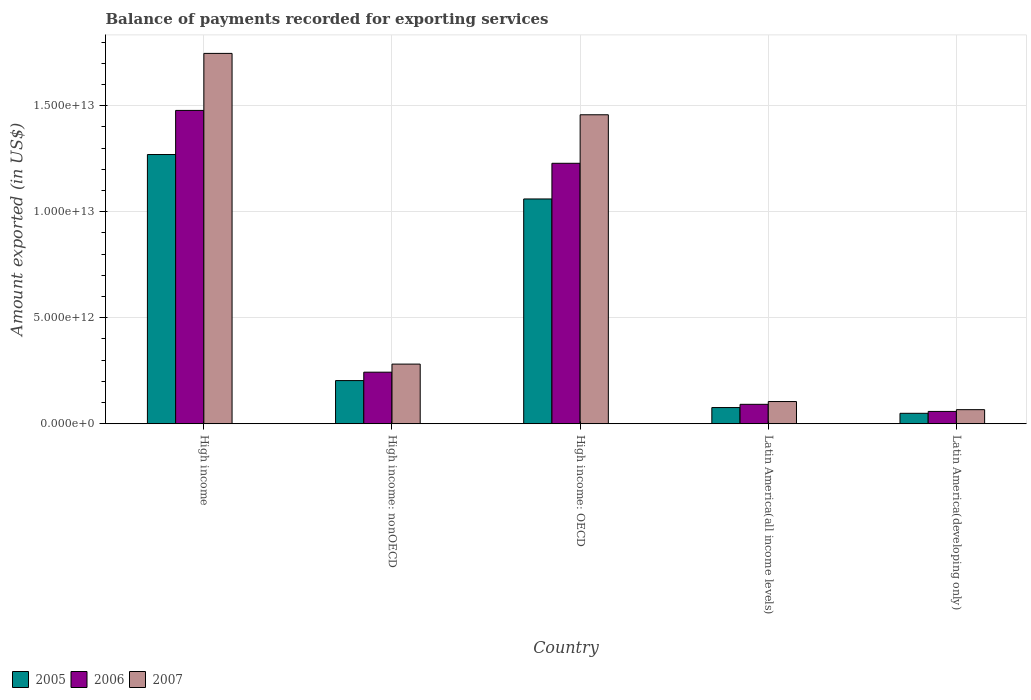How many different coloured bars are there?
Offer a terse response. 3. Are the number of bars on each tick of the X-axis equal?
Provide a succinct answer. Yes. How many bars are there on the 5th tick from the left?
Offer a very short reply. 3. What is the label of the 5th group of bars from the left?
Provide a succinct answer. Latin America(developing only). What is the amount exported in 2006 in Latin America(all income levels)?
Offer a very short reply. 9.16e+11. Across all countries, what is the maximum amount exported in 2007?
Provide a succinct answer. 1.75e+13. Across all countries, what is the minimum amount exported in 2006?
Offer a very short reply. 5.81e+11. In which country was the amount exported in 2006 maximum?
Ensure brevity in your answer.  High income. In which country was the amount exported in 2006 minimum?
Give a very brief answer. Latin America(developing only). What is the total amount exported in 2005 in the graph?
Your answer should be compact. 2.66e+13. What is the difference between the amount exported in 2005 in High income: nonOECD and that in Latin America(all income levels)?
Provide a succinct answer. 1.27e+12. What is the difference between the amount exported in 2005 in Latin America(developing only) and the amount exported in 2006 in High income: OECD?
Provide a succinct answer. -1.18e+13. What is the average amount exported in 2005 per country?
Your answer should be compact. 5.32e+12. What is the difference between the amount exported of/in 2006 and amount exported of/in 2007 in Latin America(developing only)?
Provide a short and direct response. -8.33e+1. In how many countries, is the amount exported in 2007 greater than 10000000000000 US$?
Give a very brief answer. 2. What is the ratio of the amount exported in 2007 in High income: OECD to that in Latin America(developing only)?
Ensure brevity in your answer.  21.95. Is the amount exported in 2007 in High income less than that in Latin America(all income levels)?
Make the answer very short. No. What is the difference between the highest and the second highest amount exported in 2007?
Your response must be concise. 1.18e+13. What is the difference between the highest and the lowest amount exported in 2005?
Keep it short and to the point. 1.22e+13. In how many countries, is the amount exported in 2007 greater than the average amount exported in 2007 taken over all countries?
Offer a very short reply. 2. What does the 3rd bar from the left in High income represents?
Provide a short and direct response. 2007. Are all the bars in the graph horizontal?
Provide a succinct answer. No. How many countries are there in the graph?
Your response must be concise. 5. What is the difference between two consecutive major ticks on the Y-axis?
Your answer should be compact. 5.00e+12. Are the values on the major ticks of Y-axis written in scientific E-notation?
Your response must be concise. Yes. Does the graph contain any zero values?
Your response must be concise. No. Where does the legend appear in the graph?
Your answer should be very brief. Bottom left. How are the legend labels stacked?
Your response must be concise. Horizontal. What is the title of the graph?
Ensure brevity in your answer.  Balance of payments recorded for exporting services. Does "1960" appear as one of the legend labels in the graph?
Make the answer very short. No. What is the label or title of the Y-axis?
Your response must be concise. Amount exported (in US$). What is the Amount exported (in US$) in 2005 in High income?
Your answer should be compact. 1.27e+13. What is the Amount exported (in US$) in 2006 in High income?
Make the answer very short. 1.48e+13. What is the Amount exported (in US$) in 2007 in High income?
Offer a terse response. 1.75e+13. What is the Amount exported (in US$) in 2005 in High income: nonOECD?
Give a very brief answer. 2.04e+12. What is the Amount exported (in US$) of 2006 in High income: nonOECD?
Your response must be concise. 2.43e+12. What is the Amount exported (in US$) in 2007 in High income: nonOECD?
Give a very brief answer. 2.81e+12. What is the Amount exported (in US$) in 2005 in High income: OECD?
Your answer should be compact. 1.06e+13. What is the Amount exported (in US$) in 2006 in High income: OECD?
Your answer should be compact. 1.23e+13. What is the Amount exported (in US$) of 2007 in High income: OECD?
Ensure brevity in your answer.  1.46e+13. What is the Amount exported (in US$) in 2005 in Latin America(all income levels)?
Keep it short and to the point. 7.63e+11. What is the Amount exported (in US$) of 2006 in Latin America(all income levels)?
Provide a succinct answer. 9.16e+11. What is the Amount exported (in US$) in 2007 in Latin America(all income levels)?
Ensure brevity in your answer.  1.05e+12. What is the Amount exported (in US$) in 2005 in Latin America(developing only)?
Provide a short and direct response. 4.92e+11. What is the Amount exported (in US$) in 2006 in Latin America(developing only)?
Provide a succinct answer. 5.81e+11. What is the Amount exported (in US$) in 2007 in Latin America(developing only)?
Offer a very short reply. 6.64e+11. Across all countries, what is the maximum Amount exported (in US$) of 2005?
Provide a short and direct response. 1.27e+13. Across all countries, what is the maximum Amount exported (in US$) in 2006?
Your answer should be very brief. 1.48e+13. Across all countries, what is the maximum Amount exported (in US$) of 2007?
Offer a terse response. 1.75e+13. Across all countries, what is the minimum Amount exported (in US$) in 2005?
Offer a very short reply. 4.92e+11. Across all countries, what is the minimum Amount exported (in US$) in 2006?
Ensure brevity in your answer.  5.81e+11. Across all countries, what is the minimum Amount exported (in US$) in 2007?
Ensure brevity in your answer.  6.64e+11. What is the total Amount exported (in US$) in 2005 in the graph?
Keep it short and to the point. 2.66e+13. What is the total Amount exported (in US$) in 2006 in the graph?
Give a very brief answer. 3.10e+13. What is the total Amount exported (in US$) of 2007 in the graph?
Ensure brevity in your answer.  3.66e+13. What is the difference between the Amount exported (in US$) of 2005 in High income and that in High income: nonOECD?
Keep it short and to the point. 1.07e+13. What is the difference between the Amount exported (in US$) in 2006 in High income and that in High income: nonOECD?
Keep it short and to the point. 1.23e+13. What is the difference between the Amount exported (in US$) of 2007 in High income and that in High income: nonOECD?
Your answer should be compact. 1.47e+13. What is the difference between the Amount exported (in US$) in 2005 in High income and that in High income: OECD?
Ensure brevity in your answer.  2.10e+12. What is the difference between the Amount exported (in US$) in 2006 in High income and that in High income: OECD?
Your response must be concise. 2.49e+12. What is the difference between the Amount exported (in US$) of 2007 in High income and that in High income: OECD?
Your answer should be very brief. 2.90e+12. What is the difference between the Amount exported (in US$) of 2005 in High income and that in Latin America(all income levels)?
Your answer should be compact. 1.19e+13. What is the difference between the Amount exported (in US$) in 2006 in High income and that in Latin America(all income levels)?
Offer a very short reply. 1.39e+13. What is the difference between the Amount exported (in US$) of 2007 in High income and that in Latin America(all income levels)?
Ensure brevity in your answer.  1.64e+13. What is the difference between the Amount exported (in US$) in 2005 in High income and that in Latin America(developing only)?
Your answer should be very brief. 1.22e+13. What is the difference between the Amount exported (in US$) of 2006 in High income and that in Latin America(developing only)?
Your response must be concise. 1.42e+13. What is the difference between the Amount exported (in US$) of 2007 in High income and that in Latin America(developing only)?
Your answer should be compact. 1.68e+13. What is the difference between the Amount exported (in US$) of 2005 in High income: nonOECD and that in High income: OECD?
Your response must be concise. -8.57e+12. What is the difference between the Amount exported (in US$) of 2006 in High income: nonOECD and that in High income: OECD?
Ensure brevity in your answer.  -9.85e+12. What is the difference between the Amount exported (in US$) in 2007 in High income: nonOECD and that in High income: OECD?
Your answer should be very brief. -1.18e+13. What is the difference between the Amount exported (in US$) of 2005 in High income: nonOECD and that in Latin America(all income levels)?
Offer a very short reply. 1.27e+12. What is the difference between the Amount exported (in US$) of 2006 in High income: nonOECD and that in Latin America(all income levels)?
Your answer should be very brief. 1.52e+12. What is the difference between the Amount exported (in US$) in 2007 in High income: nonOECD and that in Latin America(all income levels)?
Provide a succinct answer. 1.77e+12. What is the difference between the Amount exported (in US$) of 2005 in High income: nonOECD and that in Latin America(developing only)?
Your answer should be compact. 1.54e+12. What is the difference between the Amount exported (in US$) of 2006 in High income: nonOECD and that in Latin America(developing only)?
Make the answer very short. 1.85e+12. What is the difference between the Amount exported (in US$) in 2007 in High income: nonOECD and that in Latin America(developing only)?
Give a very brief answer. 2.15e+12. What is the difference between the Amount exported (in US$) in 2005 in High income: OECD and that in Latin America(all income levels)?
Provide a succinct answer. 9.84e+12. What is the difference between the Amount exported (in US$) in 2006 in High income: OECD and that in Latin America(all income levels)?
Your answer should be compact. 1.14e+13. What is the difference between the Amount exported (in US$) of 2007 in High income: OECD and that in Latin America(all income levels)?
Offer a very short reply. 1.35e+13. What is the difference between the Amount exported (in US$) in 2005 in High income: OECD and that in Latin America(developing only)?
Offer a terse response. 1.01e+13. What is the difference between the Amount exported (in US$) in 2006 in High income: OECD and that in Latin America(developing only)?
Ensure brevity in your answer.  1.17e+13. What is the difference between the Amount exported (in US$) of 2007 in High income: OECD and that in Latin America(developing only)?
Offer a terse response. 1.39e+13. What is the difference between the Amount exported (in US$) of 2005 in Latin America(all income levels) and that in Latin America(developing only)?
Offer a very short reply. 2.71e+11. What is the difference between the Amount exported (in US$) in 2006 in Latin America(all income levels) and that in Latin America(developing only)?
Provide a succinct answer. 3.35e+11. What is the difference between the Amount exported (in US$) in 2007 in Latin America(all income levels) and that in Latin America(developing only)?
Your answer should be compact. 3.83e+11. What is the difference between the Amount exported (in US$) in 2005 in High income and the Amount exported (in US$) in 2006 in High income: nonOECD?
Keep it short and to the point. 1.03e+13. What is the difference between the Amount exported (in US$) in 2005 in High income and the Amount exported (in US$) in 2007 in High income: nonOECD?
Offer a very short reply. 9.89e+12. What is the difference between the Amount exported (in US$) in 2006 in High income and the Amount exported (in US$) in 2007 in High income: nonOECD?
Give a very brief answer. 1.20e+13. What is the difference between the Amount exported (in US$) of 2005 in High income and the Amount exported (in US$) of 2006 in High income: OECD?
Offer a very short reply. 4.13e+11. What is the difference between the Amount exported (in US$) in 2005 in High income and the Amount exported (in US$) in 2007 in High income: OECD?
Offer a terse response. -1.88e+12. What is the difference between the Amount exported (in US$) in 2006 in High income and the Amount exported (in US$) in 2007 in High income: OECD?
Your answer should be compact. 2.05e+11. What is the difference between the Amount exported (in US$) of 2005 in High income and the Amount exported (in US$) of 2006 in Latin America(all income levels)?
Your answer should be very brief. 1.18e+13. What is the difference between the Amount exported (in US$) in 2005 in High income and the Amount exported (in US$) in 2007 in Latin America(all income levels)?
Provide a succinct answer. 1.17e+13. What is the difference between the Amount exported (in US$) of 2006 in High income and the Amount exported (in US$) of 2007 in Latin America(all income levels)?
Offer a terse response. 1.37e+13. What is the difference between the Amount exported (in US$) in 2005 in High income and the Amount exported (in US$) in 2006 in Latin America(developing only)?
Offer a terse response. 1.21e+13. What is the difference between the Amount exported (in US$) in 2005 in High income and the Amount exported (in US$) in 2007 in Latin America(developing only)?
Your answer should be very brief. 1.20e+13. What is the difference between the Amount exported (in US$) of 2006 in High income and the Amount exported (in US$) of 2007 in Latin America(developing only)?
Your response must be concise. 1.41e+13. What is the difference between the Amount exported (in US$) of 2005 in High income: nonOECD and the Amount exported (in US$) of 2006 in High income: OECD?
Provide a short and direct response. -1.03e+13. What is the difference between the Amount exported (in US$) of 2005 in High income: nonOECD and the Amount exported (in US$) of 2007 in High income: OECD?
Make the answer very short. -1.25e+13. What is the difference between the Amount exported (in US$) of 2006 in High income: nonOECD and the Amount exported (in US$) of 2007 in High income: OECD?
Make the answer very short. -1.21e+13. What is the difference between the Amount exported (in US$) in 2005 in High income: nonOECD and the Amount exported (in US$) in 2006 in Latin America(all income levels)?
Provide a short and direct response. 1.12e+12. What is the difference between the Amount exported (in US$) in 2005 in High income: nonOECD and the Amount exported (in US$) in 2007 in Latin America(all income levels)?
Your answer should be very brief. 9.88e+11. What is the difference between the Amount exported (in US$) in 2006 in High income: nonOECD and the Amount exported (in US$) in 2007 in Latin America(all income levels)?
Your answer should be very brief. 1.38e+12. What is the difference between the Amount exported (in US$) of 2005 in High income: nonOECD and the Amount exported (in US$) of 2006 in Latin America(developing only)?
Provide a short and direct response. 1.45e+12. What is the difference between the Amount exported (in US$) in 2005 in High income: nonOECD and the Amount exported (in US$) in 2007 in Latin America(developing only)?
Make the answer very short. 1.37e+12. What is the difference between the Amount exported (in US$) in 2006 in High income: nonOECD and the Amount exported (in US$) in 2007 in Latin America(developing only)?
Make the answer very short. 1.77e+12. What is the difference between the Amount exported (in US$) in 2005 in High income: OECD and the Amount exported (in US$) in 2006 in Latin America(all income levels)?
Your answer should be very brief. 9.69e+12. What is the difference between the Amount exported (in US$) in 2005 in High income: OECD and the Amount exported (in US$) in 2007 in Latin America(all income levels)?
Provide a short and direct response. 9.56e+12. What is the difference between the Amount exported (in US$) in 2006 in High income: OECD and the Amount exported (in US$) in 2007 in Latin America(all income levels)?
Your answer should be very brief. 1.12e+13. What is the difference between the Amount exported (in US$) of 2005 in High income: OECD and the Amount exported (in US$) of 2006 in Latin America(developing only)?
Provide a short and direct response. 1.00e+13. What is the difference between the Amount exported (in US$) of 2005 in High income: OECD and the Amount exported (in US$) of 2007 in Latin America(developing only)?
Your answer should be very brief. 9.94e+12. What is the difference between the Amount exported (in US$) in 2006 in High income: OECD and the Amount exported (in US$) in 2007 in Latin America(developing only)?
Your answer should be very brief. 1.16e+13. What is the difference between the Amount exported (in US$) of 2005 in Latin America(all income levels) and the Amount exported (in US$) of 2006 in Latin America(developing only)?
Offer a terse response. 1.82e+11. What is the difference between the Amount exported (in US$) in 2005 in Latin America(all income levels) and the Amount exported (in US$) in 2007 in Latin America(developing only)?
Provide a short and direct response. 9.91e+1. What is the difference between the Amount exported (in US$) in 2006 in Latin America(all income levels) and the Amount exported (in US$) in 2007 in Latin America(developing only)?
Your answer should be very brief. 2.52e+11. What is the average Amount exported (in US$) of 2005 per country?
Provide a short and direct response. 5.32e+12. What is the average Amount exported (in US$) of 2006 per country?
Provide a short and direct response. 6.20e+12. What is the average Amount exported (in US$) of 2007 per country?
Provide a succinct answer. 7.31e+12. What is the difference between the Amount exported (in US$) in 2005 and Amount exported (in US$) in 2006 in High income?
Make the answer very short. -2.08e+12. What is the difference between the Amount exported (in US$) in 2005 and Amount exported (in US$) in 2007 in High income?
Provide a succinct answer. -4.77e+12. What is the difference between the Amount exported (in US$) of 2006 and Amount exported (in US$) of 2007 in High income?
Offer a terse response. -2.69e+12. What is the difference between the Amount exported (in US$) of 2005 and Amount exported (in US$) of 2006 in High income: nonOECD?
Your answer should be compact. -3.97e+11. What is the difference between the Amount exported (in US$) of 2005 and Amount exported (in US$) of 2007 in High income: nonOECD?
Ensure brevity in your answer.  -7.78e+11. What is the difference between the Amount exported (in US$) of 2006 and Amount exported (in US$) of 2007 in High income: nonOECD?
Offer a very short reply. -3.82e+11. What is the difference between the Amount exported (in US$) of 2005 and Amount exported (in US$) of 2006 in High income: OECD?
Ensure brevity in your answer.  -1.68e+12. What is the difference between the Amount exported (in US$) in 2005 and Amount exported (in US$) in 2007 in High income: OECD?
Your answer should be very brief. -3.97e+12. What is the difference between the Amount exported (in US$) of 2006 and Amount exported (in US$) of 2007 in High income: OECD?
Your answer should be very brief. -2.29e+12. What is the difference between the Amount exported (in US$) in 2005 and Amount exported (in US$) in 2006 in Latin America(all income levels)?
Offer a terse response. -1.53e+11. What is the difference between the Amount exported (in US$) in 2005 and Amount exported (in US$) in 2007 in Latin America(all income levels)?
Provide a short and direct response. -2.84e+11. What is the difference between the Amount exported (in US$) of 2006 and Amount exported (in US$) of 2007 in Latin America(all income levels)?
Ensure brevity in your answer.  -1.31e+11. What is the difference between the Amount exported (in US$) of 2005 and Amount exported (in US$) of 2006 in Latin America(developing only)?
Keep it short and to the point. -8.89e+1. What is the difference between the Amount exported (in US$) in 2005 and Amount exported (in US$) in 2007 in Latin America(developing only)?
Keep it short and to the point. -1.72e+11. What is the difference between the Amount exported (in US$) of 2006 and Amount exported (in US$) of 2007 in Latin America(developing only)?
Your answer should be very brief. -8.33e+1. What is the ratio of the Amount exported (in US$) in 2005 in High income to that in High income: nonOECD?
Ensure brevity in your answer.  6.24. What is the ratio of the Amount exported (in US$) in 2006 in High income to that in High income: nonOECD?
Give a very brief answer. 6.08. What is the ratio of the Amount exported (in US$) of 2007 in High income to that in High income: nonOECD?
Offer a very short reply. 6.21. What is the ratio of the Amount exported (in US$) in 2005 in High income to that in High income: OECD?
Provide a short and direct response. 1.2. What is the ratio of the Amount exported (in US$) in 2006 in High income to that in High income: OECD?
Offer a very short reply. 1.2. What is the ratio of the Amount exported (in US$) in 2007 in High income to that in High income: OECD?
Your answer should be very brief. 1.2. What is the ratio of the Amount exported (in US$) of 2005 in High income to that in Latin America(all income levels)?
Your answer should be compact. 16.64. What is the ratio of the Amount exported (in US$) in 2006 in High income to that in Latin America(all income levels)?
Your answer should be very brief. 16.13. What is the ratio of the Amount exported (in US$) in 2007 in High income to that in Latin America(all income levels)?
Provide a short and direct response. 16.68. What is the ratio of the Amount exported (in US$) in 2005 in High income to that in Latin America(developing only)?
Offer a terse response. 25.82. What is the ratio of the Amount exported (in US$) of 2006 in High income to that in Latin America(developing only)?
Ensure brevity in your answer.  25.45. What is the ratio of the Amount exported (in US$) of 2007 in High income to that in Latin America(developing only)?
Your answer should be compact. 26.31. What is the ratio of the Amount exported (in US$) in 2005 in High income: nonOECD to that in High income: OECD?
Give a very brief answer. 0.19. What is the ratio of the Amount exported (in US$) of 2006 in High income: nonOECD to that in High income: OECD?
Keep it short and to the point. 0.2. What is the ratio of the Amount exported (in US$) in 2007 in High income: nonOECD to that in High income: OECD?
Your response must be concise. 0.19. What is the ratio of the Amount exported (in US$) in 2005 in High income: nonOECD to that in Latin America(all income levels)?
Offer a very short reply. 2.67. What is the ratio of the Amount exported (in US$) in 2006 in High income: nonOECD to that in Latin America(all income levels)?
Provide a short and direct response. 2.65. What is the ratio of the Amount exported (in US$) of 2007 in High income: nonOECD to that in Latin America(all income levels)?
Provide a succinct answer. 2.69. What is the ratio of the Amount exported (in US$) of 2005 in High income: nonOECD to that in Latin America(developing only)?
Offer a very short reply. 4.14. What is the ratio of the Amount exported (in US$) of 2006 in High income: nonOECD to that in Latin America(developing only)?
Offer a terse response. 4.19. What is the ratio of the Amount exported (in US$) of 2007 in High income: nonOECD to that in Latin America(developing only)?
Make the answer very short. 4.24. What is the ratio of the Amount exported (in US$) in 2005 in High income: OECD to that in Latin America(all income levels)?
Make the answer very short. 13.89. What is the ratio of the Amount exported (in US$) of 2006 in High income: OECD to that in Latin America(all income levels)?
Provide a short and direct response. 13.41. What is the ratio of the Amount exported (in US$) of 2007 in High income: OECD to that in Latin America(all income levels)?
Offer a very short reply. 13.91. What is the ratio of the Amount exported (in US$) in 2005 in High income: OECD to that in Latin America(developing only)?
Keep it short and to the point. 21.56. What is the ratio of the Amount exported (in US$) in 2006 in High income: OECD to that in Latin America(developing only)?
Your response must be concise. 21.16. What is the ratio of the Amount exported (in US$) in 2007 in High income: OECD to that in Latin America(developing only)?
Offer a terse response. 21.95. What is the ratio of the Amount exported (in US$) in 2005 in Latin America(all income levels) to that in Latin America(developing only)?
Give a very brief answer. 1.55. What is the ratio of the Amount exported (in US$) in 2006 in Latin America(all income levels) to that in Latin America(developing only)?
Provide a short and direct response. 1.58. What is the ratio of the Amount exported (in US$) in 2007 in Latin America(all income levels) to that in Latin America(developing only)?
Provide a succinct answer. 1.58. What is the difference between the highest and the second highest Amount exported (in US$) of 2005?
Make the answer very short. 2.10e+12. What is the difference between the highest and the second highest Amount exported (in US$) in 2006?
Your response must be concise. 2.49e+12. What is the difference between the highest and the second highest Amount exported (in US$) of 2007?
Ensure brevity in your answer.  2.90e+12. What is the difference between the highest and the lowest Amount exported (in US$) in 2005?
Offer a very short reply. 1.22e+13. What is the difference between the highest and the lowest Amount exported (in US$) of 2006?
Ensure brevity in your answer.  1.42e+13. What is the difference between the highest and the lowest Amount exported (in US$) of 2007?
Provide a short and direct response. 1.68e+13. 